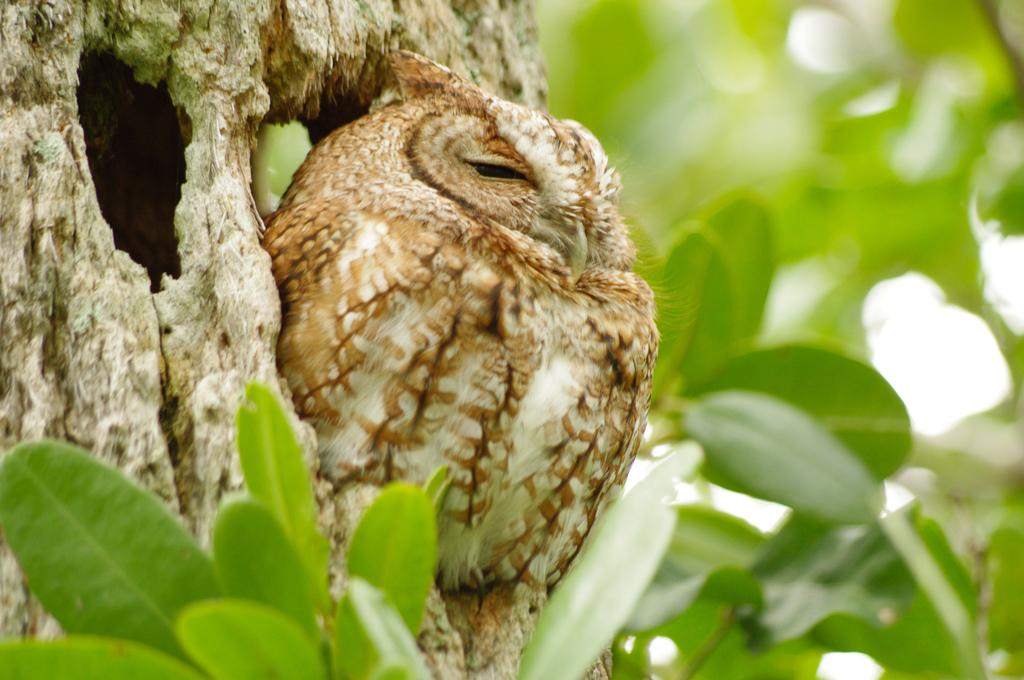What is the main subject in the middle of the image? There is a bird in the middle of the image. What else can be seen in the image besides the bird? There are leaves in the image. Where is the bomb located in the image? There is no bomb present in the image. What type of dolls can be seen playing with the sea in the image? There are no dolls or sea present in the image; it features a bird and leaves. 